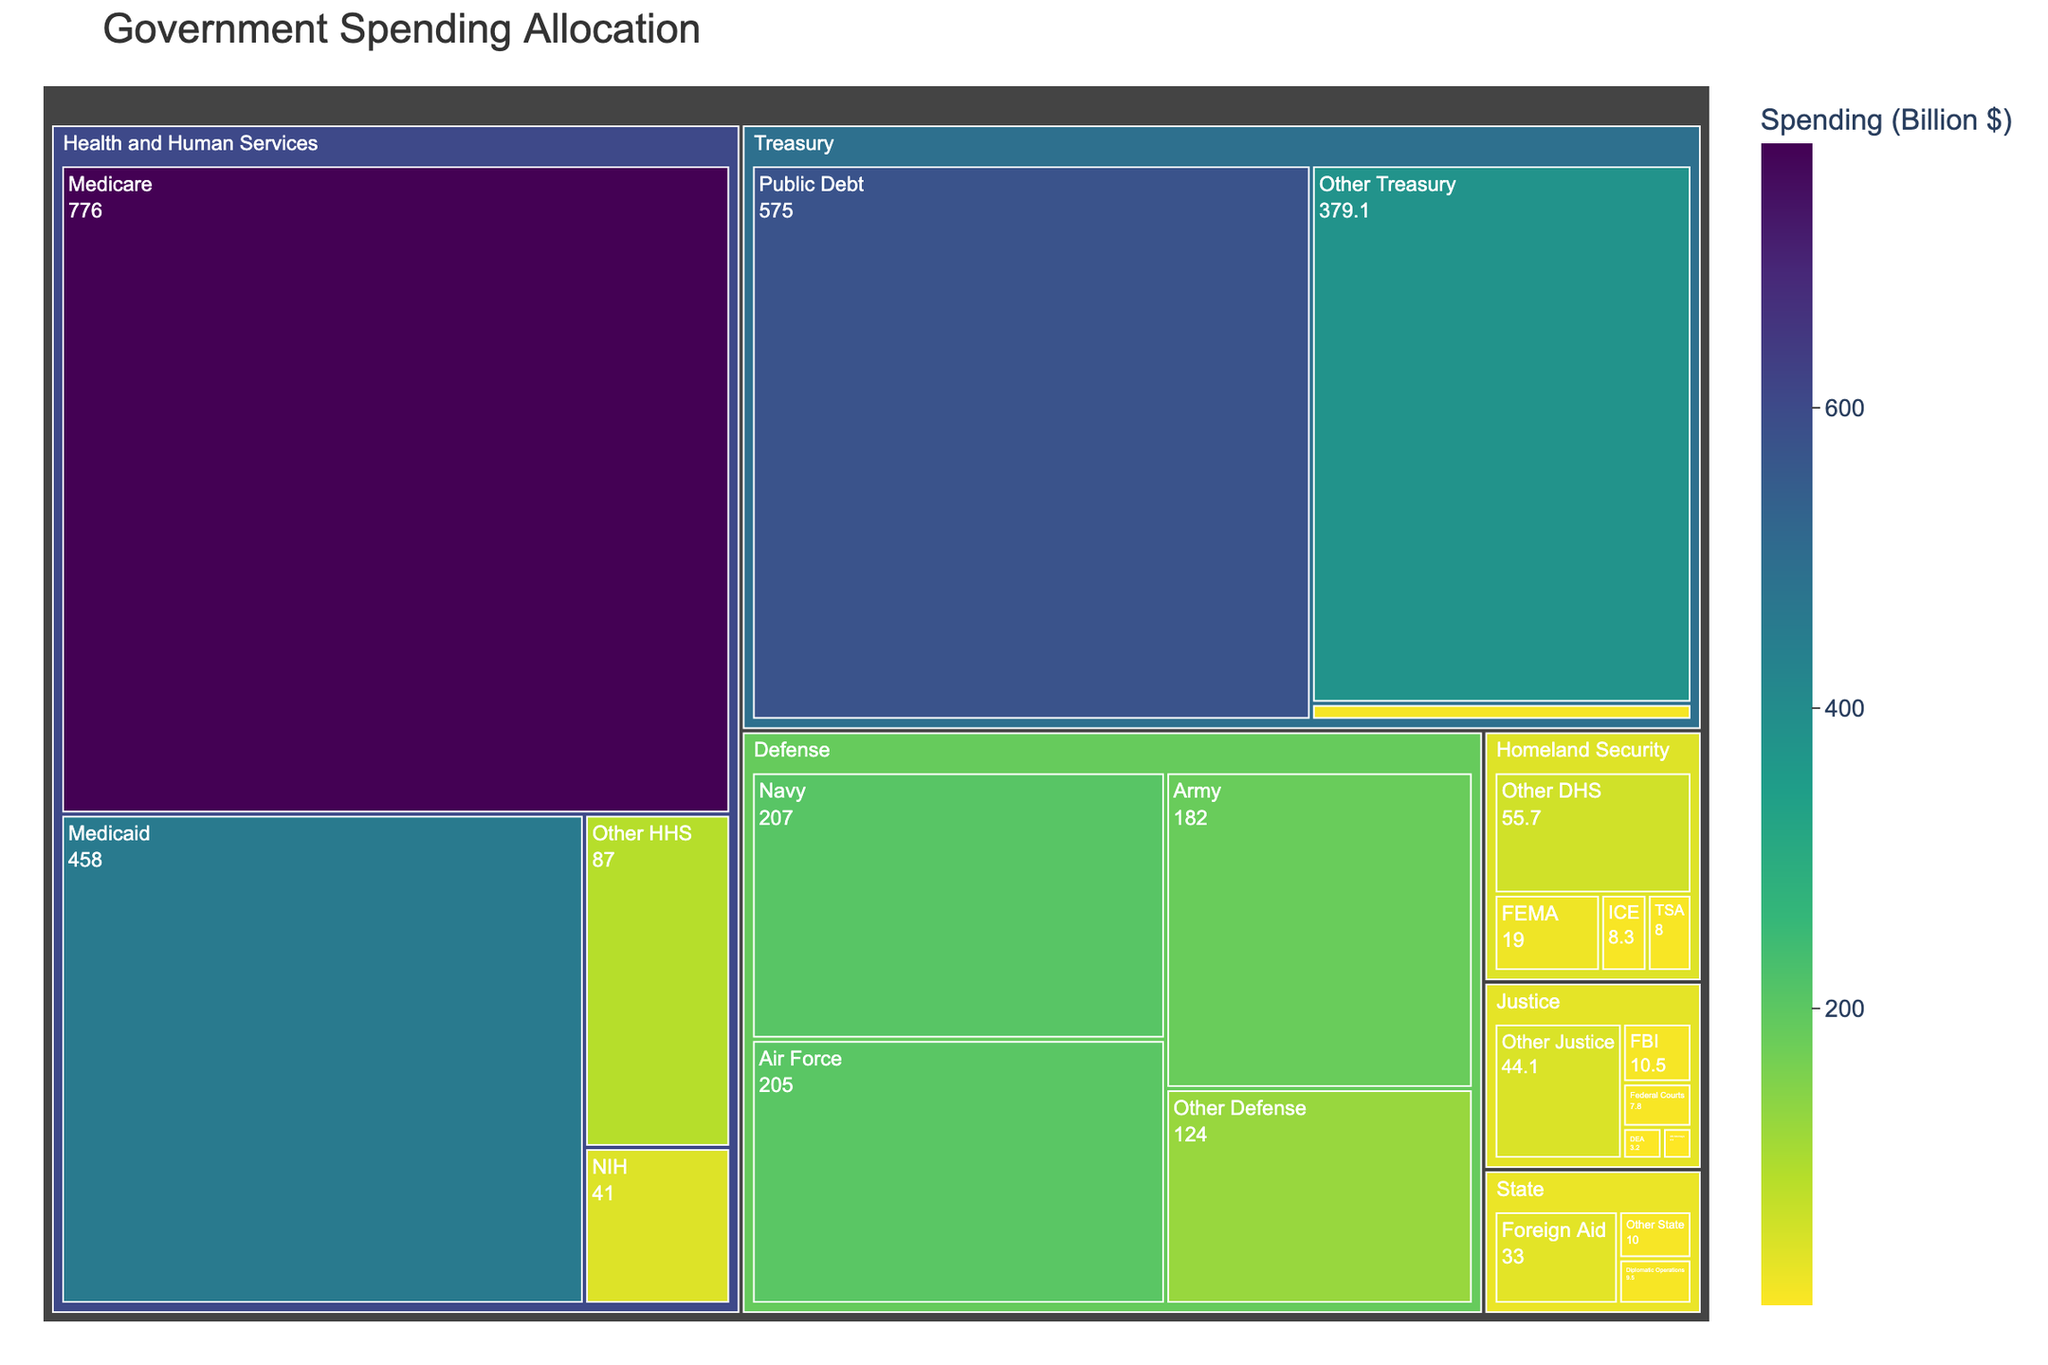What is the total spending of the Department of Homeland Security? The total spending of the Department of Homeland Security is indicated on the Treemap as a whole, which is $91.0 billion.
Answer: $91.0 billion How much more is spent on the Medicare program compared to the Medicaid program within Health and Human Services? Medicare spending is $776.0 billion and Medicaid spending is $458.0 billion. The difference can be calculated as $776.0 billion - $458.0 billion = $318.0 billion.
Answer: $318.0 billion Which department has the highest overall spending? By looking at the largest segmented area in the Treemap, the department with the highest spending is Health and Human Services with $1362.0 billion.
Answer: Health and Human Services What is the combined spending of the subdivisions under the Treasury department other than Public Debt? The subdivisions other than Public Debt (IRS and Other Treasury) spend $11.9 billion and $379.1 billion respectively. Adding these gives $11.9 billion + $379.1 billion = $391.0 billion.
Answer: $391.0 billion How does the spending of the FBI in the Justice Department compare to the spending of FEMA in Homeland Security? The spending of the FBI is $10.5 billion and the spending of FEMA is $19.0 billion. FEMA spends $19.0 billion - $10.5 billion = $8.5 billion more than the FBI.
Answer: FEMA spends $8.5 billion more Are there any subdivisions in the Defense department spending more than $200 billion? Within the Defense department, the Navy and Air Force subdivisions are allocated $207.0 billion and $205.0 billion respectively, which are both more than $200 billion.
Answer: Yes, Navy and Air Force Which subdivision within the Department of Justice receives the least funding? By looking at the Treemap, the US Attorneys subdivision has the smallest allocation within the Department of Justice, with a spending of $2.4 billion.
Answer: US Attorneys What is the spending difference between the Army and Other Defense within the Defense Department? The Army's spending is $182.0 billion and Other Defense is $124.0 billion. The difference is $182.0 billion - $124.0 billion = $58.0 billion.
Answer: $58.0 billion 